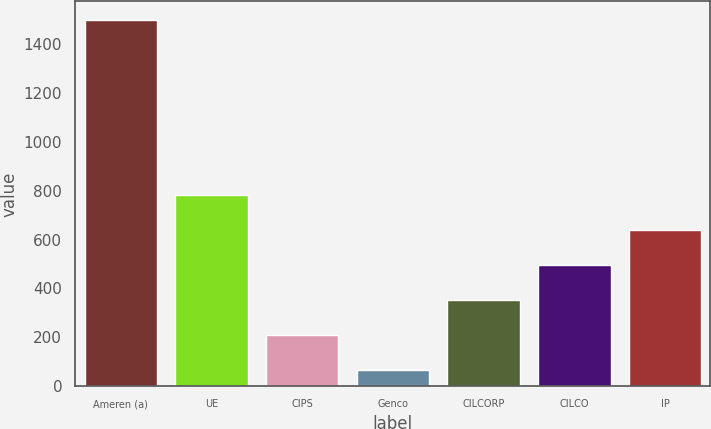Convert chart. <chart><loc_0><loc_0><loc_500><loc_500><bar_chart><fcel>Ameren (a)<fcel>UE<fcel>CIPS<fcel>Genco<fcel>CILCORP<fcel>CILCO<fcel>IP<nl><fcel>1499<fcel>783<fcel>210.2<fcel>67<fcel>353.4<fcel>496.6<fcel>639.8<nl></chart> 